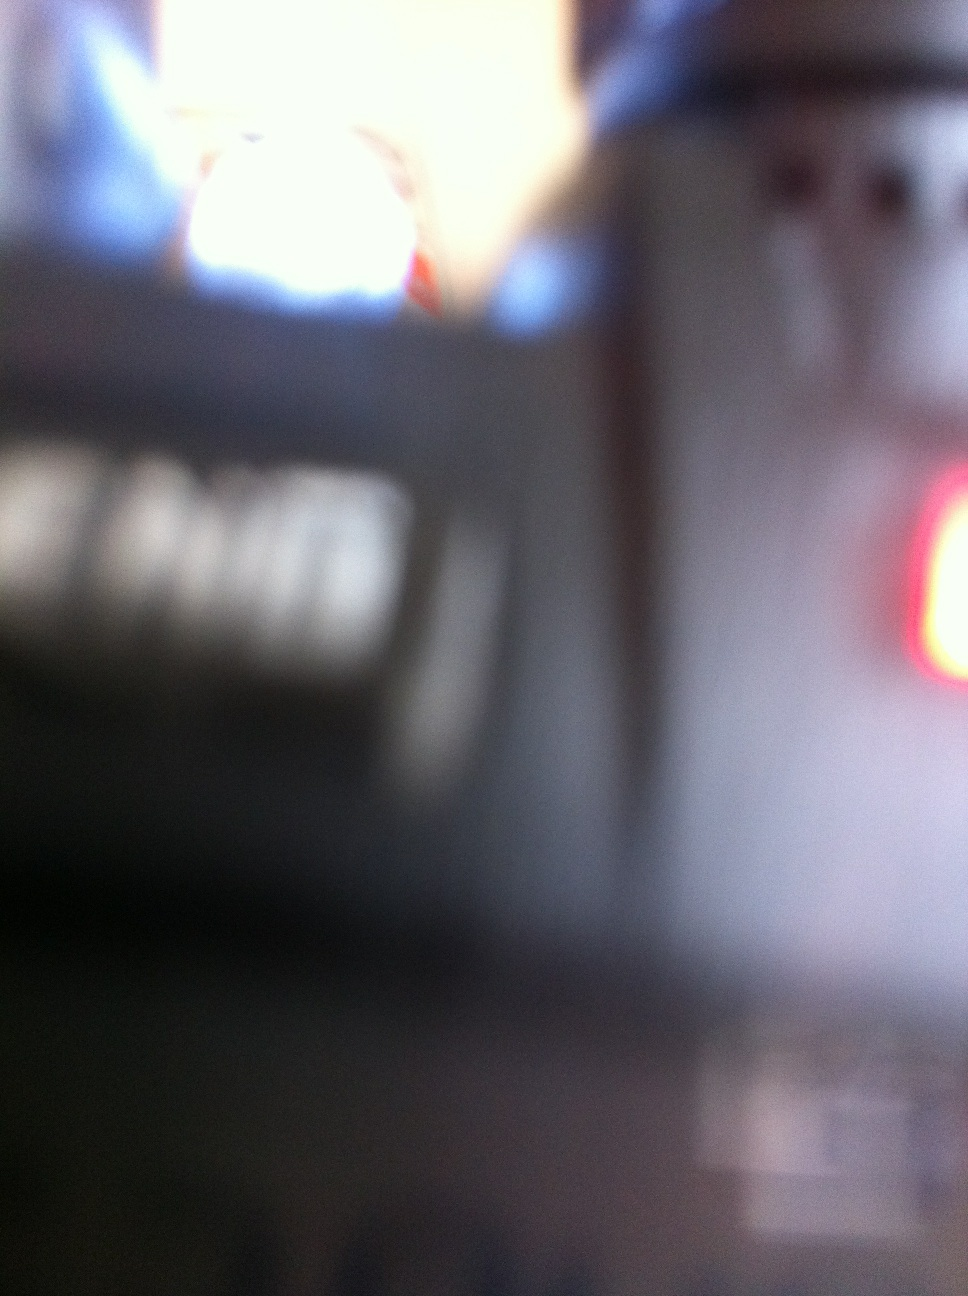Is it possible to determine the setting or context in which this image was taken? Due to the blurry nature of the image, specific details about the setting or context are indiscernible. However, given the glimpse of what appears to be a communication device like a handheld radio, it might be captured in an environment like an event, a field operation, or emergency situation where such devices are commonly used. 